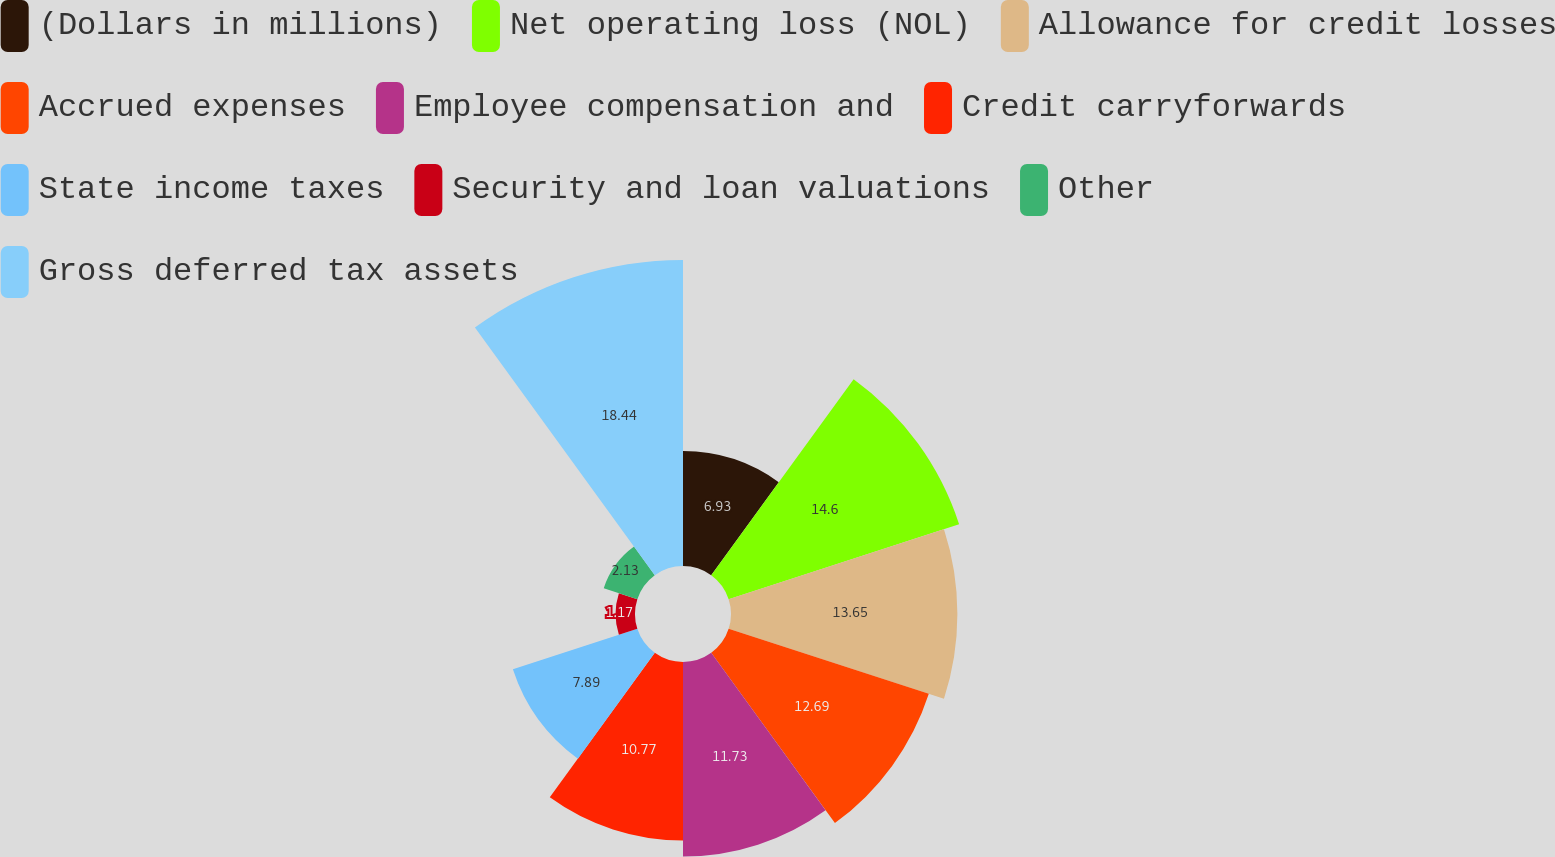Convert chart to OTSL. <chart><loc_0><loc_0><loc_500><loc_500><pie_chart><fcel>(Dollars in millions)<fcel>Net operating loss (NOL)<fcel>Allowance for credit losses<fcel>Accrued expenses<fcel>Employee compensation and<fcel>Credit carryforwards<fcel>State income taxes<fcel>Security and loan valuations<fcel>Other<fcel>Gross deferred tax assets<nl><fcel>6.93%<fcel>14.61%<fcel>13.65%<fcel>12.69%<fcel>11.73%<fcel>10.77%<fcel>7.89%<fcel>1.17%<fcel>2.13%<fcel>18.45%<nl></chart> 